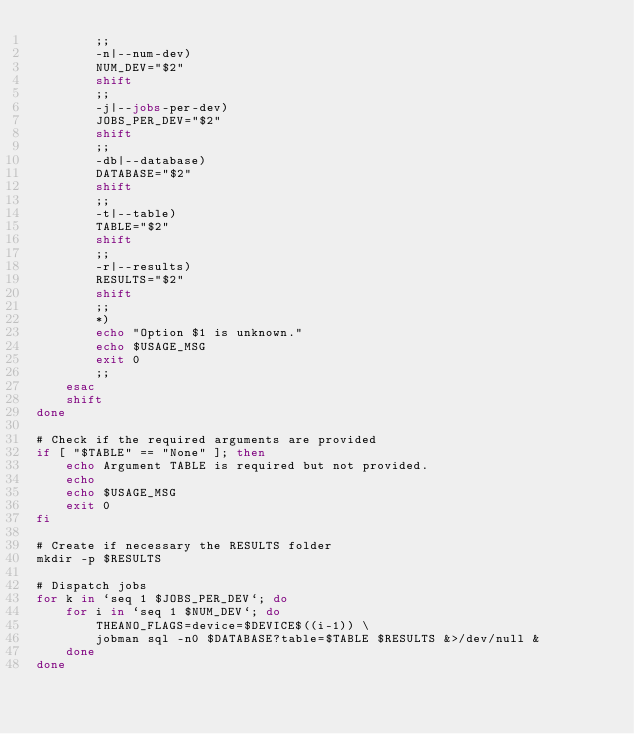Convert code to text. <code><loc_0><loc_0><loc_500><loc_500><_Bash_>        ;;
        -n|--num-dev)
        NUM_DEV="$2"
        shift
        ;;
        -j|--jobs-per-dev)
        JOBS_PER_DEV="$2"
        shift
        ;;
        -db|--database)
        DATABASE="$2"
        shift
        ;;
        -t|--table)
        TABLE="$2"
        shift
        ;;
        -r|--results)
        RESULTS="$2"
        shift
        ;;
        *)
        echo "Option $1 is unknown."
        echo $USAGE_MSG
        exit 0
        ;;
    esac
    shift
done

# Check if the required arguments are provided
if [ "$TABLE" == "None" ]; then
    echo Argument TABLE is required but not provided.
    echo
    echo $USAGE_MSG
    exit 0
fi

# Create if necessary the RESULTS folder
mkdir -p $RESULTS

# Dispatch jobs
for k in `seq 1 $JOBS_PER_DEV`; do
    for i in `seq 1 $NUM_DEV`; do
        THEANO_FLAGS=device=$DEVICE$((i-1)) \
        jobman sql -n0 $DATABASE?table=$TABLE $RESULTS &>/dev/null &
    done
done
</code> 